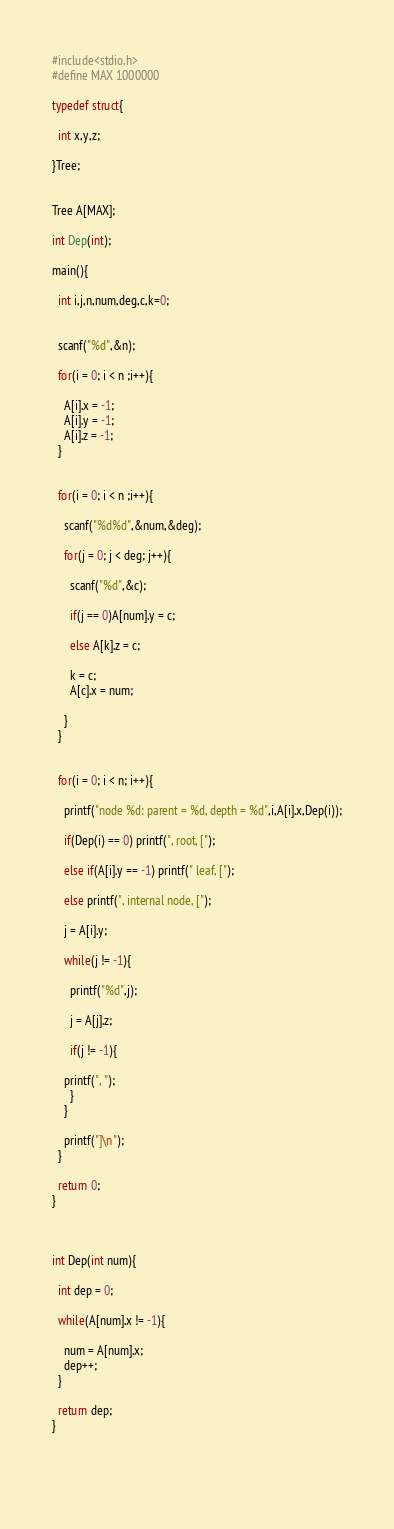Convert code to text. <code><loc_0><loc_0><loc_500><loc_500><_C_>#include<stdio.h>
#define MAX 1000000

typedef struct{

  int x,y,z;

}Tree;


Tree A[MAX];

int Dep(int);

main(){

  int i,j,n,num,deg,c,k=0;


  scanf("%d",&n);

  for(i = 0; i < n ;i++){

    A[i].x = -1;
    A[i].y = -1;
    A[i].z = -1;
  }


  for(i = 0; i < n ;i++){

    scanf("%d%d",&num,&deg);

    for(j = 0; j < deg; j++){

      scanf("%d",&c);

      if(j == 0)A[num].y = c;

      else A[k].z = c;

      k = c;
      A[c].x = num;

    }
  }


  for(i = 0; i < n; i++){

    printf("node %d: parent = %d, depth = %d",i,A[i].x,Dep(i));

    if(Dep(i) == 0) printf(", root, [");

    else if(A[i].y == -1) printf(" leaf, [");

    else printf(", internal node, [");

    j = A[i].y;

    while(j != -1){

      printf("%d",j);

      j = A[j].z;

      if(j != -1){

	printf(", ");
      }
    }

    printf("]\n");
  }

  return 0;
}



int Dep(int num){

  int dep = 0;

  while(A[num].x != -1){

    num = A[num].x;
    dep++;
  }

  return dep;
}
      
	  
	

</code> 